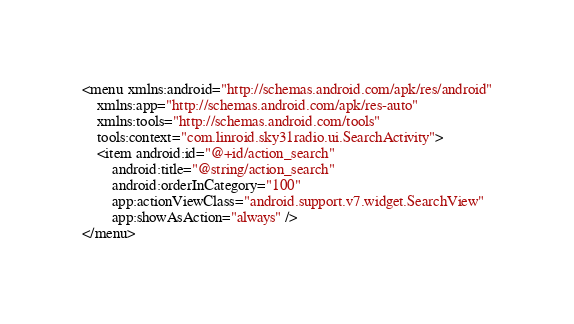<code> <loc_0><loc_0><loc_500><loc_500><_XML_><menu xmlns:android="http://schemas.android.com/apk/res/android"
    xmlns:app="http://schemas.android.com/apk/res-auto"
    xmlns:tools="http://schemas.android.com/tools"
    tools:context="com.linroid.sky31radio.ui.SearchActivity">
    <item android:id="@+id/action_search"
        android:title="@string/action_search"
        android:orderInCategory="100"
        app:actionViewClass="android.support.v7.widget.SearchView"
        app:showAsAction="always" />
</menu>
</code> 